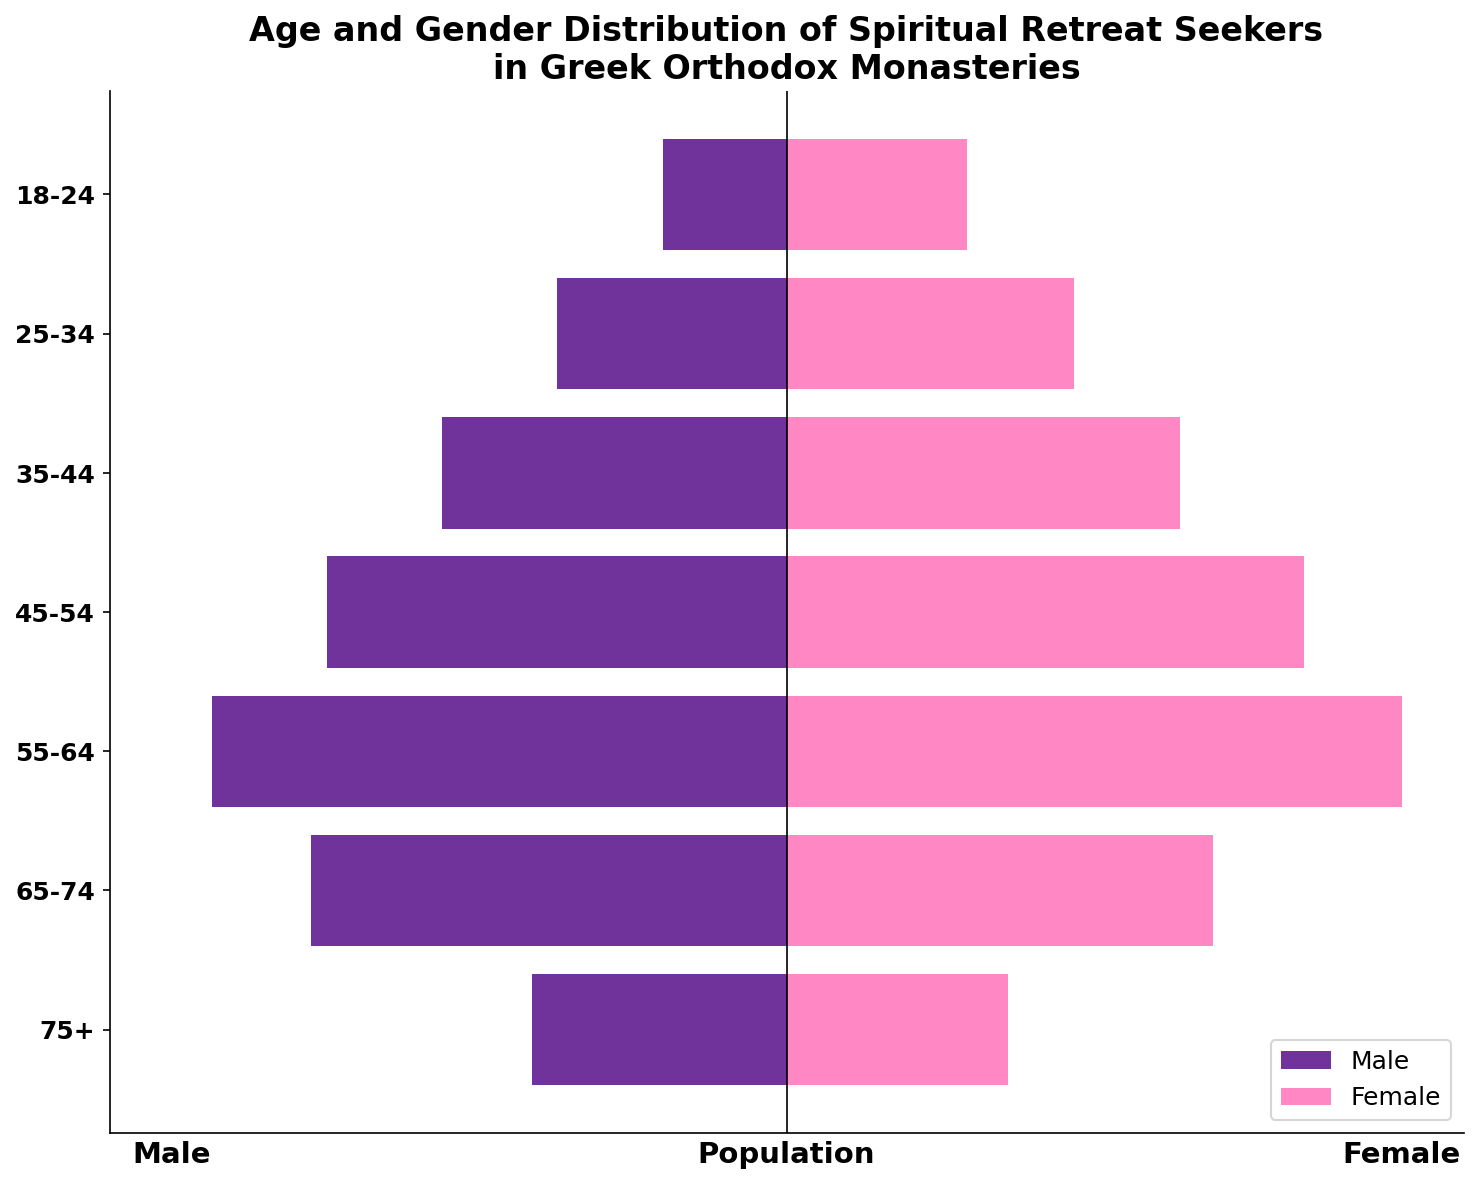What is the title of the plot? The title is located at the top of the figure and reads "Age and Gender Distribution of Spiritual Retreat Seekers in Greek Orthodox Monasteries."
Answer: Age and Gender Distribution of Spiritual Retreat Seekers in Greek Orthodox Monasteries What are the age groups represented on the y-axis? The y-axis labels each age group visually, which are: 18-24, 25-34, 35-44, 45-54, 55-64, 65-74, and 75+.
Answer: 18-24, 25-34, 35-44, 45-54, 55-64, 65-74, 75+ Which age group has the highest number of female spiritual retreat seekers? By examining the lengths of the pink bars representing females, the age group 55-64 has the longest bar, indicating the highest number of female seekers.
Answer: 55-64 What is the total number of male spiritual retreat seekers across all age groups? Add the numbers from the male data (15+28+42+56+70+58+31). A step-by-step calculation is: 15+28=43, 43+42=85, 85+56=141, 141+70=211, 211+58=269, 269+31=300.
Answer: 300 Comparing male and female seekers in the 45-54 age group, which gender has more seekers? The figure shows that the pink bar for females in the 45-54 age group is longer than the purple bar for males. To confirm, 63 (female) is greater than 56 (male).
Answer: Female In which age group is the number of male seekers closest to the number of female seekers? By examining the length of the bars, in the 65-74 age group, the number of male seekers is 58 and the number of female seekers is 52. The difference is minimal compared to other groups.
Answer: 65-74 How many more female seekers are there than male seekers in the 35-44 age group? Subtract the number of male seekers from the number of female seekers in the 35-44 age group: 48 - 42 = 6.
Answer: 6 What is the average number of female spiritual retreat seekers aged 45 and above? Calculate the average for three groups: (63 + 75 + 52 + 27)/4. The step-by-step is: 63+75=138, 138+52=190, 190+27=217; 217 / 4 = 54.25.
Answer: 54.25 Which age group has the smallest total number of spiritual retreat seekers combined (male and female)? By adding male and female figures for each age group and comparing: 18-24 has 37, 25-34 has 63, 35-44 has 90, 45-54 has 119, 55-64 has 145, 65-74 has 110, 75+ has 58. The 18-24 group has the smallest total with 37.
Answer: 18-24 Is there a vertical line in the plot, and if so, what is its significance? There is a vertical line at x=0 indicating the division between male (negative values) and female (positive values) populations, clearly partitioning the two genders on the plot.
Answer: Yes, it divides male and female seeker data 